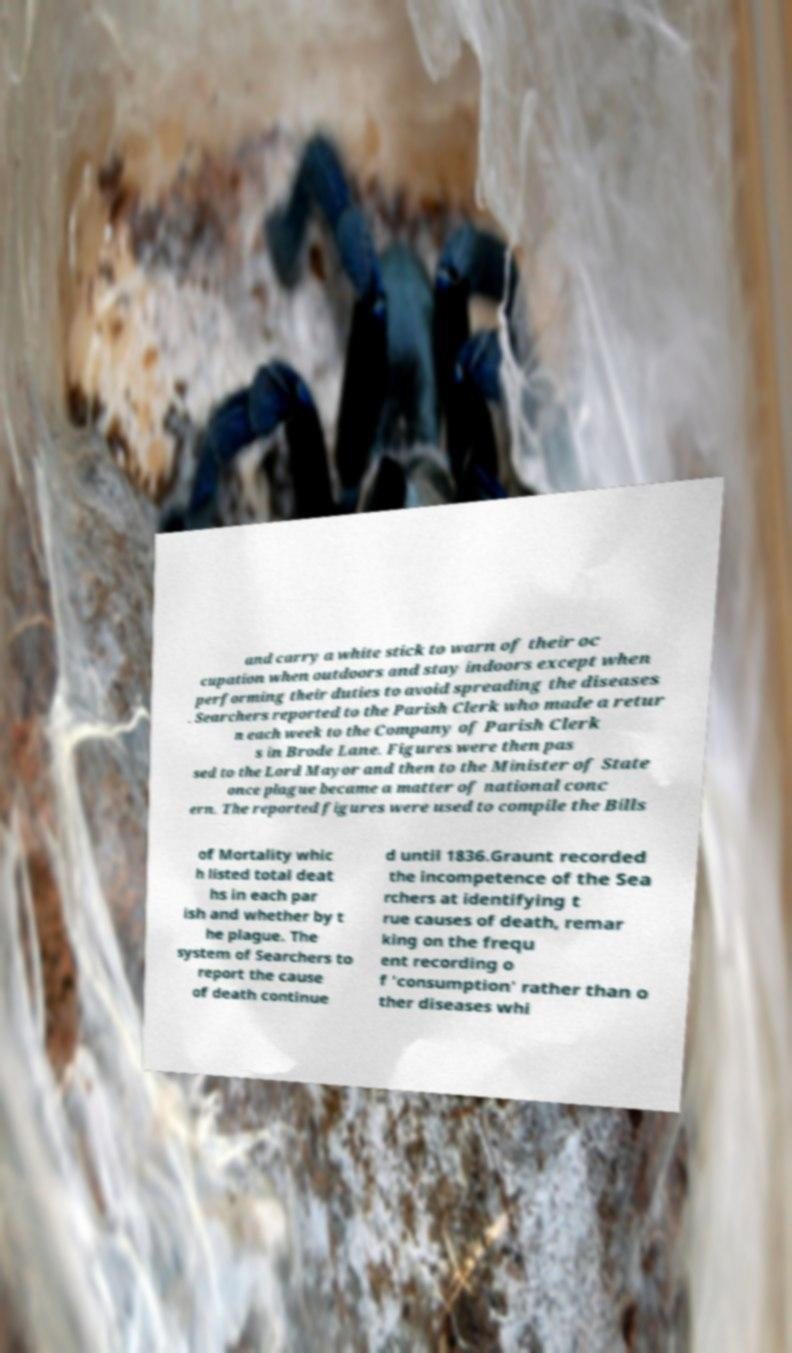Can you read and provide the text displayed in the image?This photo seems to have some interesting text. Can you extract and type it out for me? and carry a white stick to warn of their oc cupation when outdoors and stay indoors except when performing their duties to avoid spreading the diseases . Searchers reported to the Parish Clerk who made a retur n each week to the Company of Parish Clerk s in Brode Lane. Figures were then pas sed to the Lord Mayor and then to the Minister of State once plague became a matter of national conc ern. The reported figures were used to compile the Bills of Mortality whic h listed total deat hs in each par ish and whether by t he plague. The system of Searchers to report the cause of death continue d until 1836.Graunt recorded the incompetence of the Sea rchers at identifying t rue causes of death, remar king on the frequ ent recording o f 'consumption' rather than o ther diseases whi 